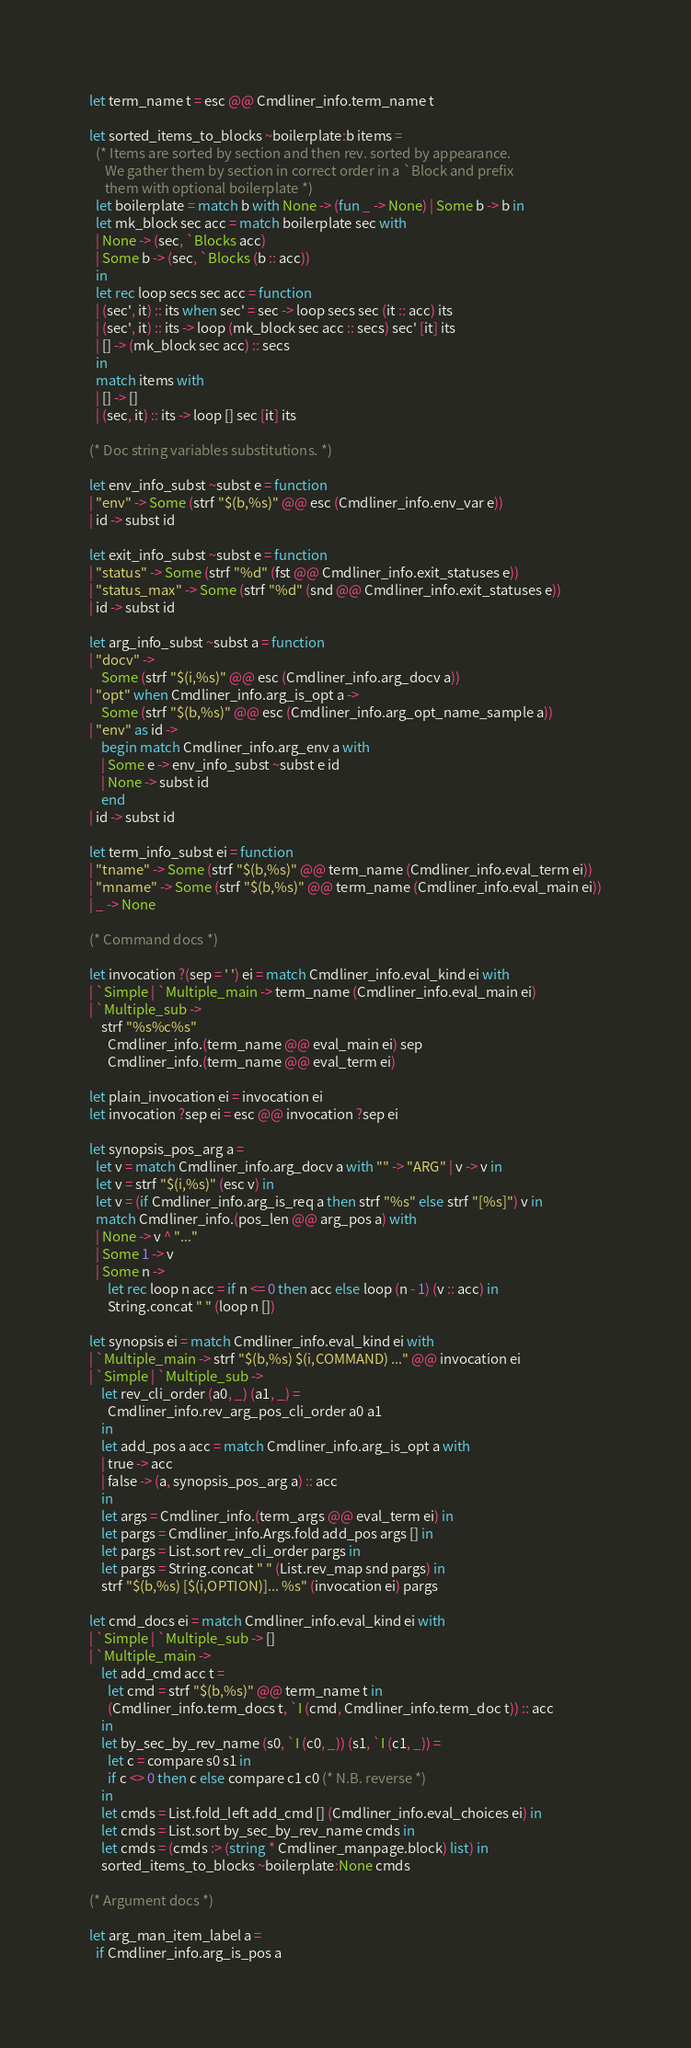<code> <loc_0><loc_0><loc_500><loc_500><_OCaml_>let term_name t = esc @@ Cmdliner_info.term_name t

let sorted_items_to_blocks ~boilerplate:b items =
  (* Items are sorted by section and then rev. sorted by appearance.
     We gather them by section in correct order in a `Block and prefix
     them with optional boilerplate *)
  let boilerplate = match b with None -> (fun _ -> None) | Some b -> b in
  let mk_block sec acc = match boilerplate sec with
  | None -> (sec, `Blocks acc)
  | Some b -> (sec, `Blocks (b :: acc))
  in
  let rec loop secs sec acc = function
  | (sec', it) :: its when sec' = sec -> loop secs sec (it :: acc) its
  | (sec', it) :: its -> loop (mk_block sec acc :: secs) sec' [it] its
  | [] -> (mk_block sec acc) :: secs
  in
  match items with
  | [] -> []
  | (sec, it) :: its -> loop [] sec [it] its

(* Doc string variables substitutions. *)

let env_info_subst ~subst e = function
| "env" -> Some (strf "$(b,%s)" @@ esc (Cmdliner_info.env_var e))
| id -> subst id

let exit_info_subst ~subst e = function
| "status" -> Some (strf "%d" (fst @@ Cmdliner_info.exit_statuses e))
| "status_max" -> Some (strf "%d" (snd @@ Cmdliner_info.exit_statuses e))
| id -> subst id

let arg_info_subst ~subst a = function
| "docv" ->
    Some (strf "$(i,%s)" @@ esc (Cmdliner_info.arg_docv a))
| "opt" when Cmdliner_info.arg_is_opt a ->
    Some (strf "$(b,%s)" @@ esc (Cmdliner_info.arg_opt_name_sample a))
| "env" as id ->
    begin match Cmdliner_info.arg_env a with
    | Some e -> env_info_subst ~subst e id
    | None -> subst id
    end
| id -> subst id

let term_info_subst ei = function
| "tname" -> Some (strf "$(b,%s)" @@ term_name (Cmdliner_info.eval_term ei))
| "mname" -> Some (strf "$(b,%s)" @@ term_name (Cmdliner_info.eval_main ei))
| _ -> None

(* Command docs *)

let invocation ?(sep = ' ') ei = match Cmdliner_info.eval_kind ei with
| `Simple | `Multiple_main -> term_name (Cmdliner_info.eval_main ei)
| `Multiple_sub ->
    strf "%s%c%s"
      Cmdliner_info.(term_name @@ eval_main ei) sep
      Cmdliner_info.(term_name @@ eval_term ei)

let plain_invocation ei = invocation ei
let invocation ?sep ei = esc @@ invocation ?sep ei

let synopsis_pos_arg a =
  let v = match Cmdliner_info.arg_docv a with "" -> "ARG" | v -> v in
  let v = strf "$(i,%s)" (esc v) in
  let v = (if Cmdliner_info.arg_is_req a then strf "%s" else strf "[%s]") v in
  match Cmdliner_info.(pos_len @@ arg_pos a) with
  | None -> v ^ "..."
  | Some 1 -> v
  | Some n ->
      let rec loop n acc = if n <= 0 then acc else loop (n - 1) (v :: acc) in
      String.concat " " (loop n [])

let synopsis ei = match Cmdliner_info.eval_kind ei with
| `Multiple_main -> strf "$(b,%s) $(i,COMMAND) ..." @@ invocation ei
| `Simple | `Multiple_sub ->
    let rev_cli_order (a0, _) (a1, _) =
      Cmdliner_info.rev_arg_pos_cli_order a0 a1
    in
    let add_pos a acc = match Cmdliner_info.arg_is_opt a with
    | true -> acc
    | false -> (a, synopsis_pos_arg a) :: acc
    in
    let args = Cmdliner_info.(term_args @@ eval_term ei) in
    let pargs = Cmdliner_info.Args.fold add_pos args [] in
    let pargs = List.sort rev_cli_order pargs in
    let pargs = String.concat " " (List.rev_map snd pargs) in
    strf "$(b,%s) [$(i,OPTION)]... %s" (invocation ei) pargs

let cmd_docs ei = match Cmdliner_info.eval_kind ei with
| `Simple | `Multiple_sub -> []
| `Multiple_main ->
    let add_cmd acc t =
      let cmd = strf "$(b,%s)" @@ term_name t in
      (Cmdliner_info.term_docs t, `I (cmd, Cmdliner_info.term_doc t)) :: acc
    in
    let by_sec_by_rev_name (s0, `I (c0, _)) (s1, `I (c1, _)) =
      let c = compare s0 s1 in
      if c <> 0 then c else compare c1 c0 (* N.B. reverse *)
    in
    let cmds = List.fold_left add_cmd [] (Cmdliner_info.eval_choices ei) in
    let cmds = List.sort by_sec_by_rev_name cmds in
    let cmds = (cmds :> (string * Cmdliner_manpage.block) list) in
    sorted_items_to_blocks ~boilerplate:None cmds

(* Argument docs *)

let arg_man_item_label a =
  if Cmdliner_info.arg_is_pos a</code> 